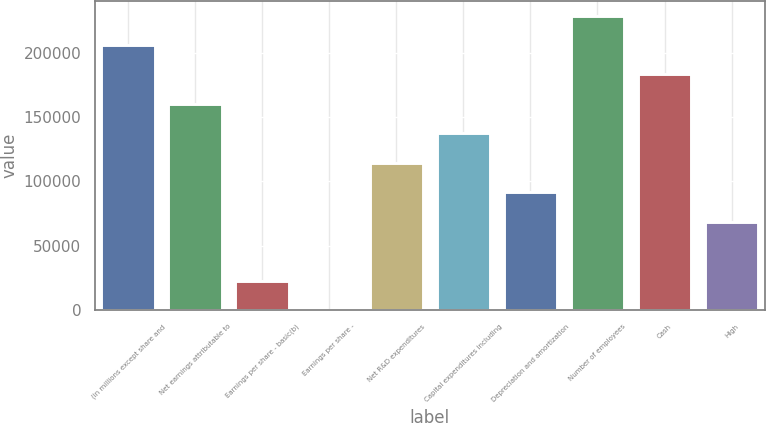<chart> <loc_0><loc_0><loc_500><loc_500><bar_chart><fcel>(in millions except share and<fcel>Net earnings attributable to<fcel>Earnings per share - basic(b)<fcel>Earnings per share -<fcel>Net R&D expenditures<fcel>Capital expenditures including<fcel>Depreciation and amortization<fcel>Number of employees<fcel>Cash<fcel>High<nl><fcel>206032<fcel>160248<fcel>22895<fcel>2.86<fcel>114463<fcel>137356<fcel>91571.3<fcel>228924<fcel>183140<fcel>68679.2<nl></chart> 